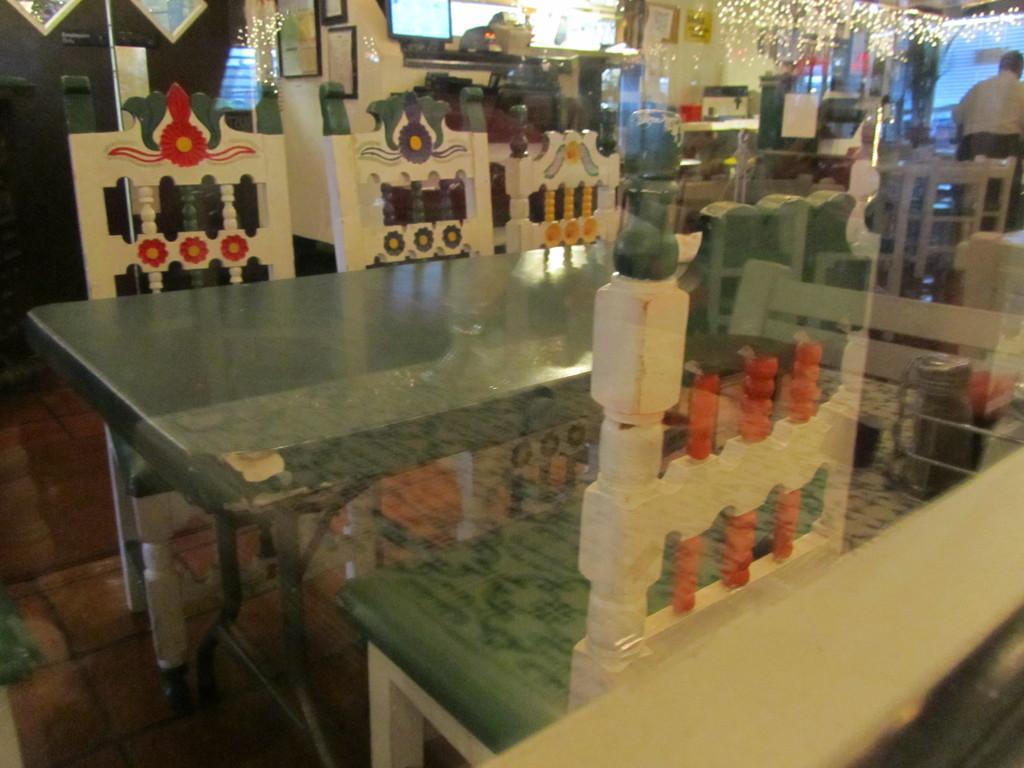In one or two sentences, can you explain what this image depicts? In this image, there are a few chairs and tables. We can see the ground, a person and the wall with some frames and objects. We can also see some black colored object and lights. We can see the reflection on tables. 